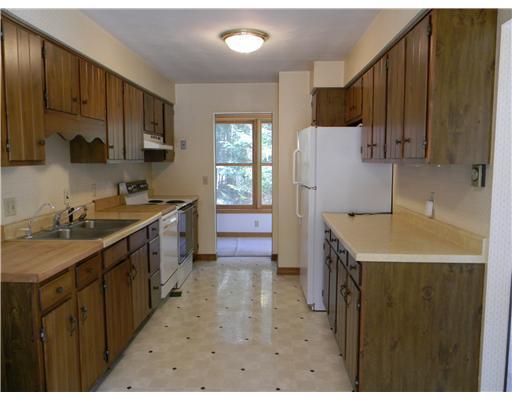How many cooks prepared meals in this kitchen today?
From the following set of four choices, select the accurate answer to respond to the question.
Options: Ten, four, five, none. None. 